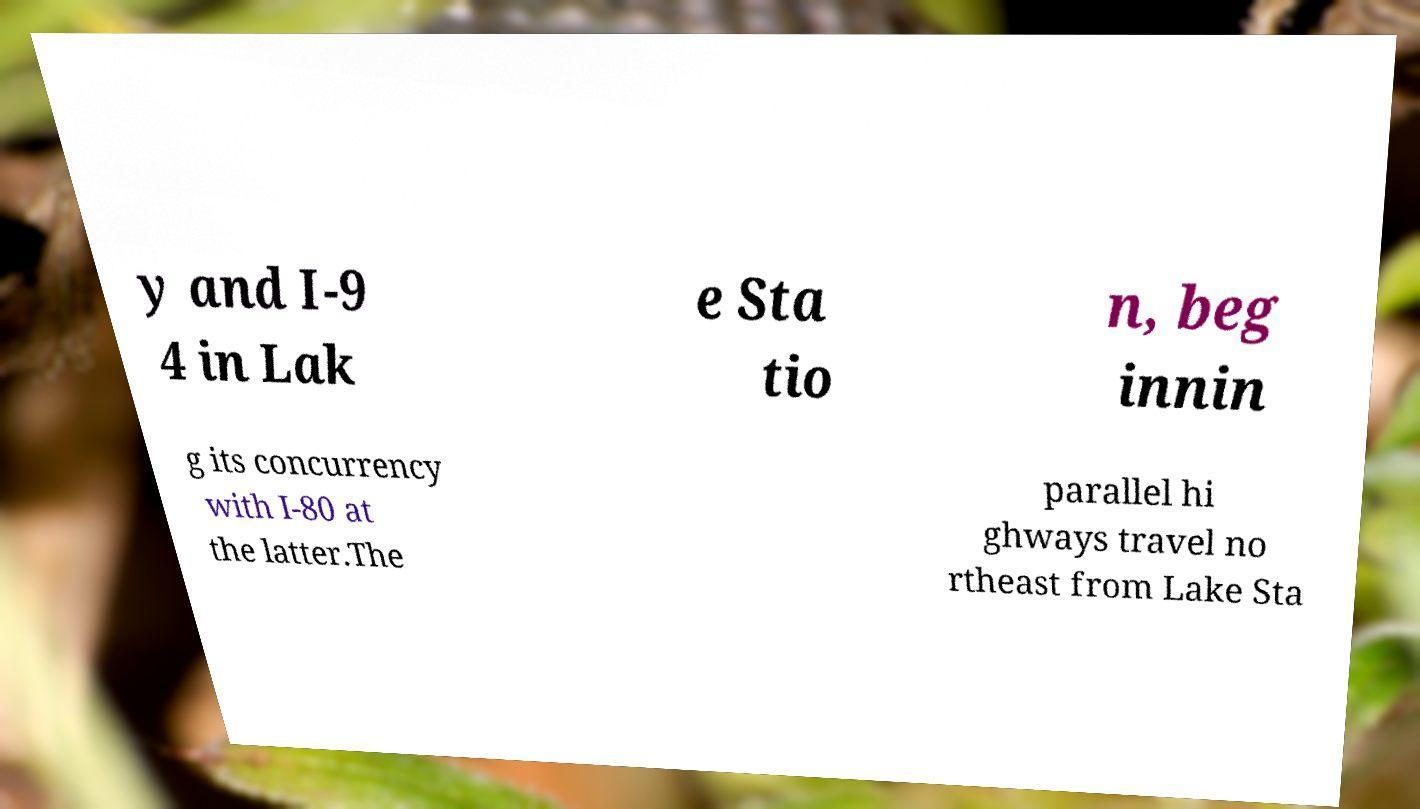Can you accurately transcribe the text from the provided image for me? y and I-9 4 in Lak e Sta tio n, beg innin g its concurrency with I-80 at the latter.The parallel hi ghways travel no rtheast from Lake Sta 